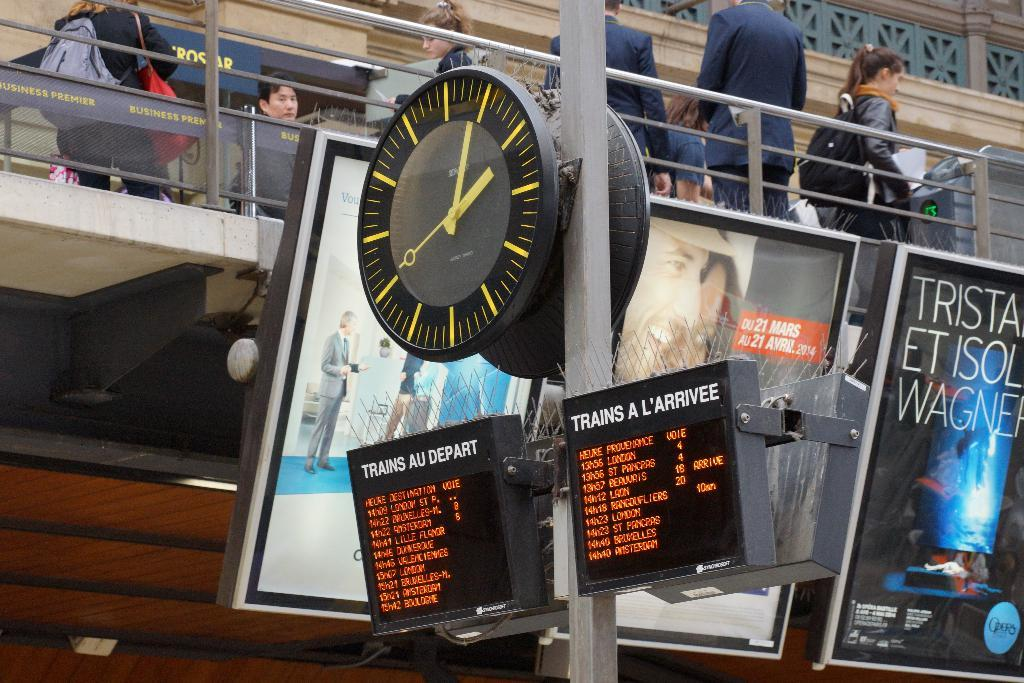Provide a one-sentence caption for the provided image. A train station with a lit up sign that says TRAIN A L'ARRIVEE and the train arrival times under it. 